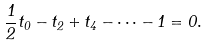<formula> <loc_0><loc_0><loc_500><loc_500>\frac { 1 } { 2 } t _ { 0 } - t _ { 2 } + t _ { 4 } - \dots - 1 = 0 .</formula> 